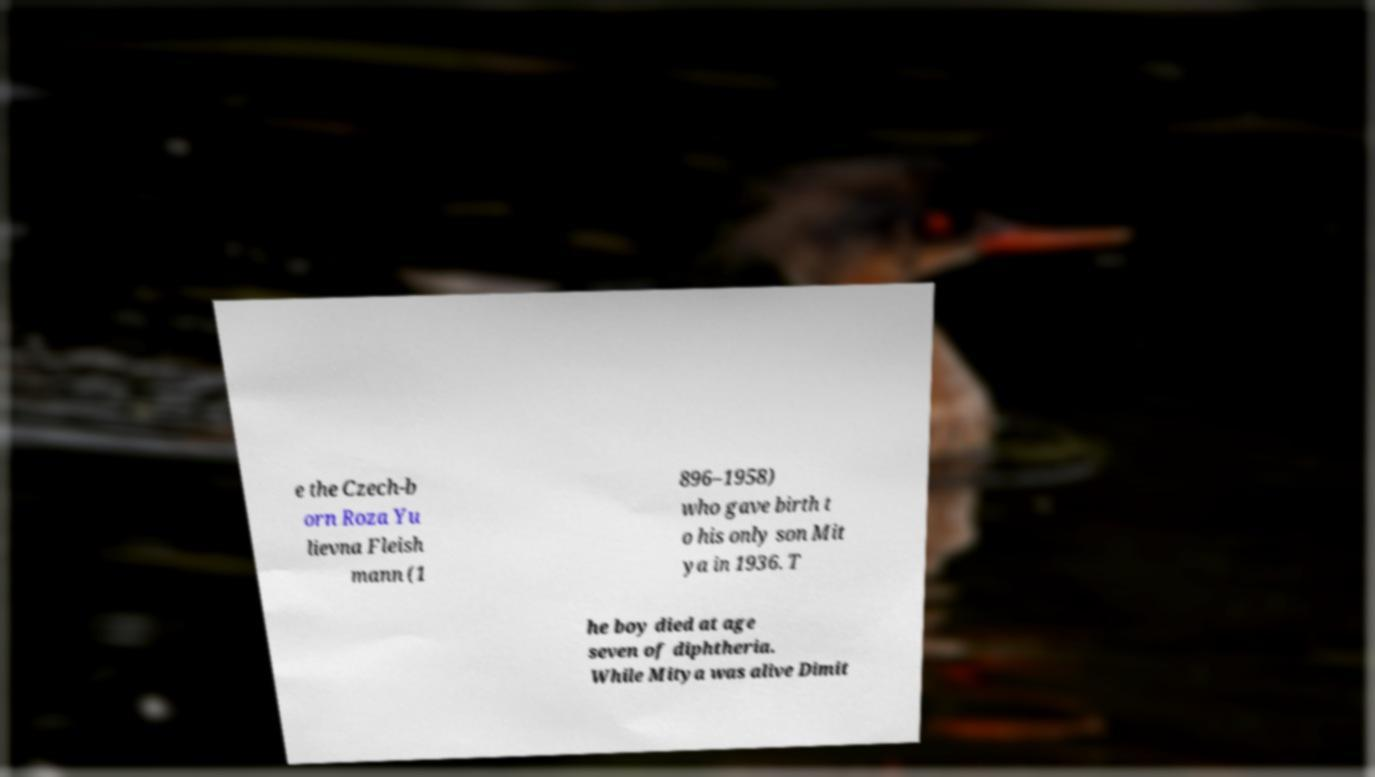For documentation purposes, I need the text within this image transcribed. Could you provide that? e the Czech-b orn Roza Yu lievna Fleish mann (1 896–1958) who gave birth t o his only son Mit ya in 1936. T he boy died at age seven of diphtheria. While Mitya was alive Dimit 